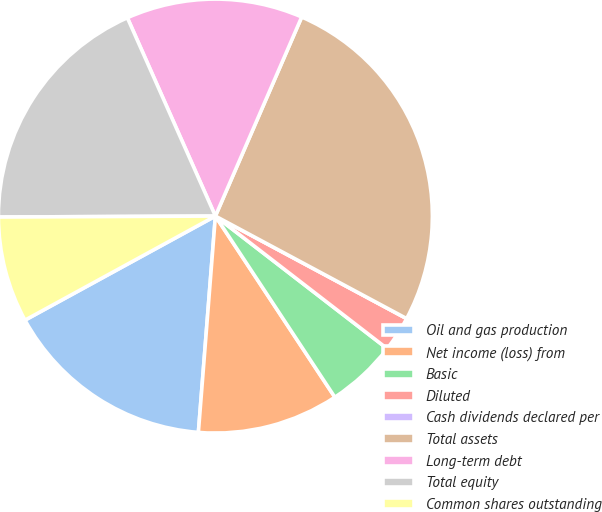Convert chart. <chart><loc_0><loc_0><loc_500><loc_500><pie_chart><fcel>Oil and gas production<fcel>Net income (loss) from<fcel>Basic<fcel>Diluted<fcel>Cash dividends declared per<fcel>Total assets<fcel>Long-term debt<fcel>Total equity<fcel>Common shares outstanding<nl><fcel>15.79%<fcel>10.53%<fcel>5.26%<fcel>2.63%<fcel>0.0%<fcel>26.32%<fcel>13.16%<fcel>18.42%<fcel>7.89%<nl></chart> 